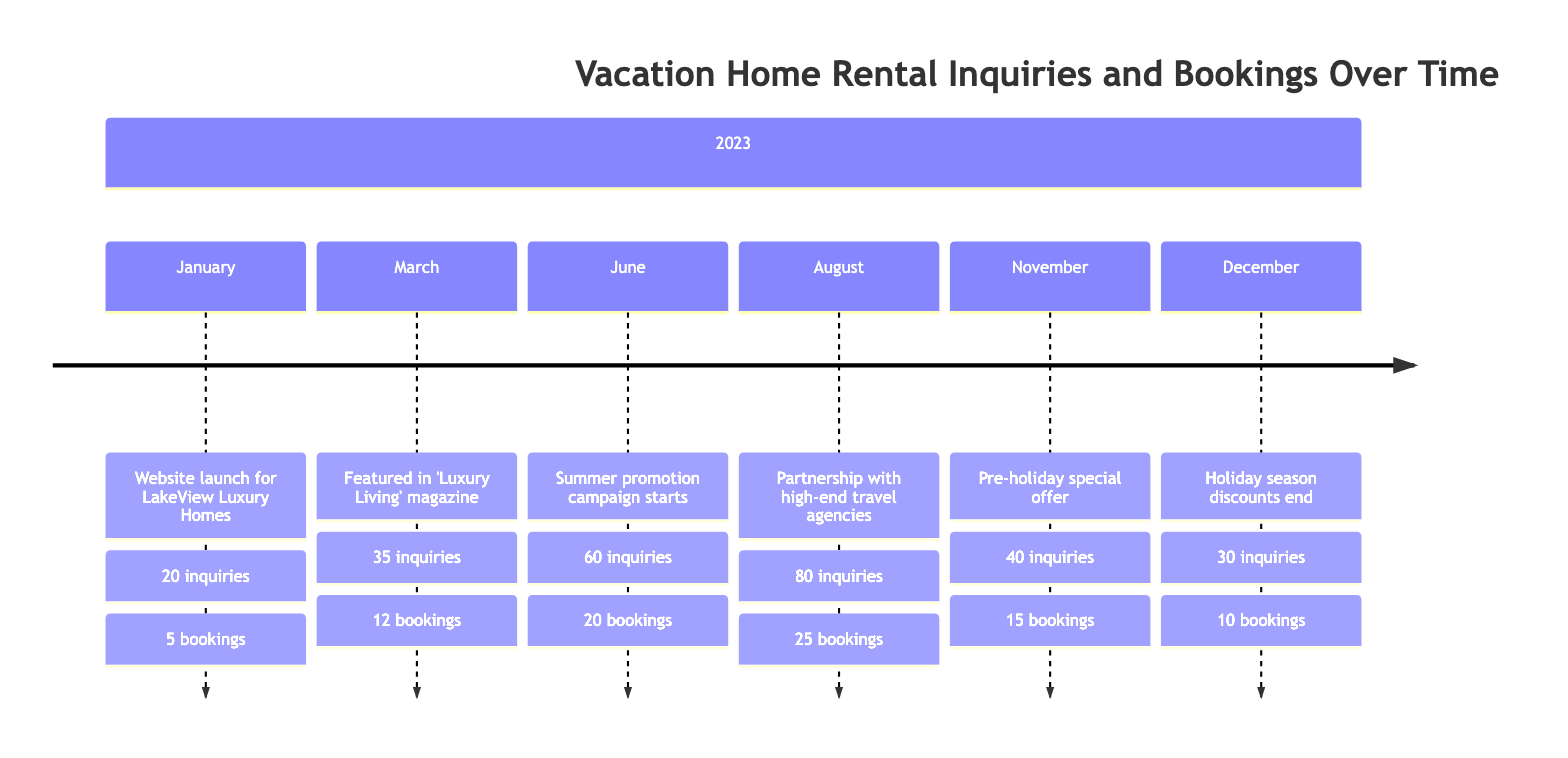What was the notable event in June? In the timeline for June, the notable event listed is the start of the summer promotion campaign.
Answer: Summer promotion campaign starts How many inquiries were there in August? The number of inquiries recorded in August is shown as 80 in the diagram.
Answer: 80 Which month had the highest number of bookings? By comparing the booking numbers, August had 25 bookings, which is the highest in the timeline.
Answer: 25 What were the total bookings from January to December? To find the total bookings, add the bookings from each month: 5 (Jan) + 12 (Mar) + 20 (Jun) + 25 (Aug) + 15 (Nov) + 10 (Dec) = 97. Therefore, the total bookings equal 97.
Answer: 97 What notable event occurred in August? The notable event noted for August is the partnership with high-end travel agencies.
Answer: Partnership with high-end travel agencies Which month saw a decrease in inquiries compared to the previous month? November shows 40 inquiries, which is a decrease compared to August's 80 inquiries. Thus, November experiences a decline in inquiries.
Answer: November How many inquiries were there in January? The inquiries for January are stated as 20 in the timeline.
Answer: 20 In which month did inquiries peak? The peak in inquiries is seen in August, which has the highest recorded value of 80 inquiries.
Answer: August 